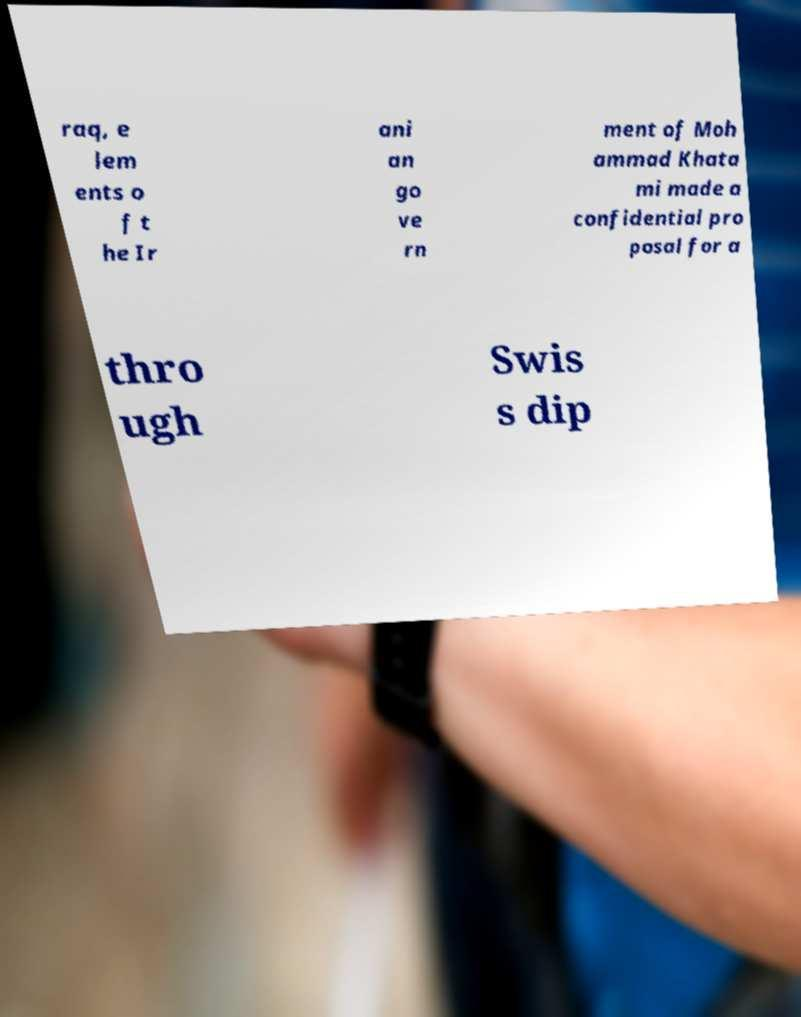There's text embedded in this image that I need extracted. Can you transcribe it verbatim? raq, e lem ents o f t he Ir ani an go ve rn ment of Moh ammad Khata mi made a confidential pro posal for a thro ugh Swis s dip 